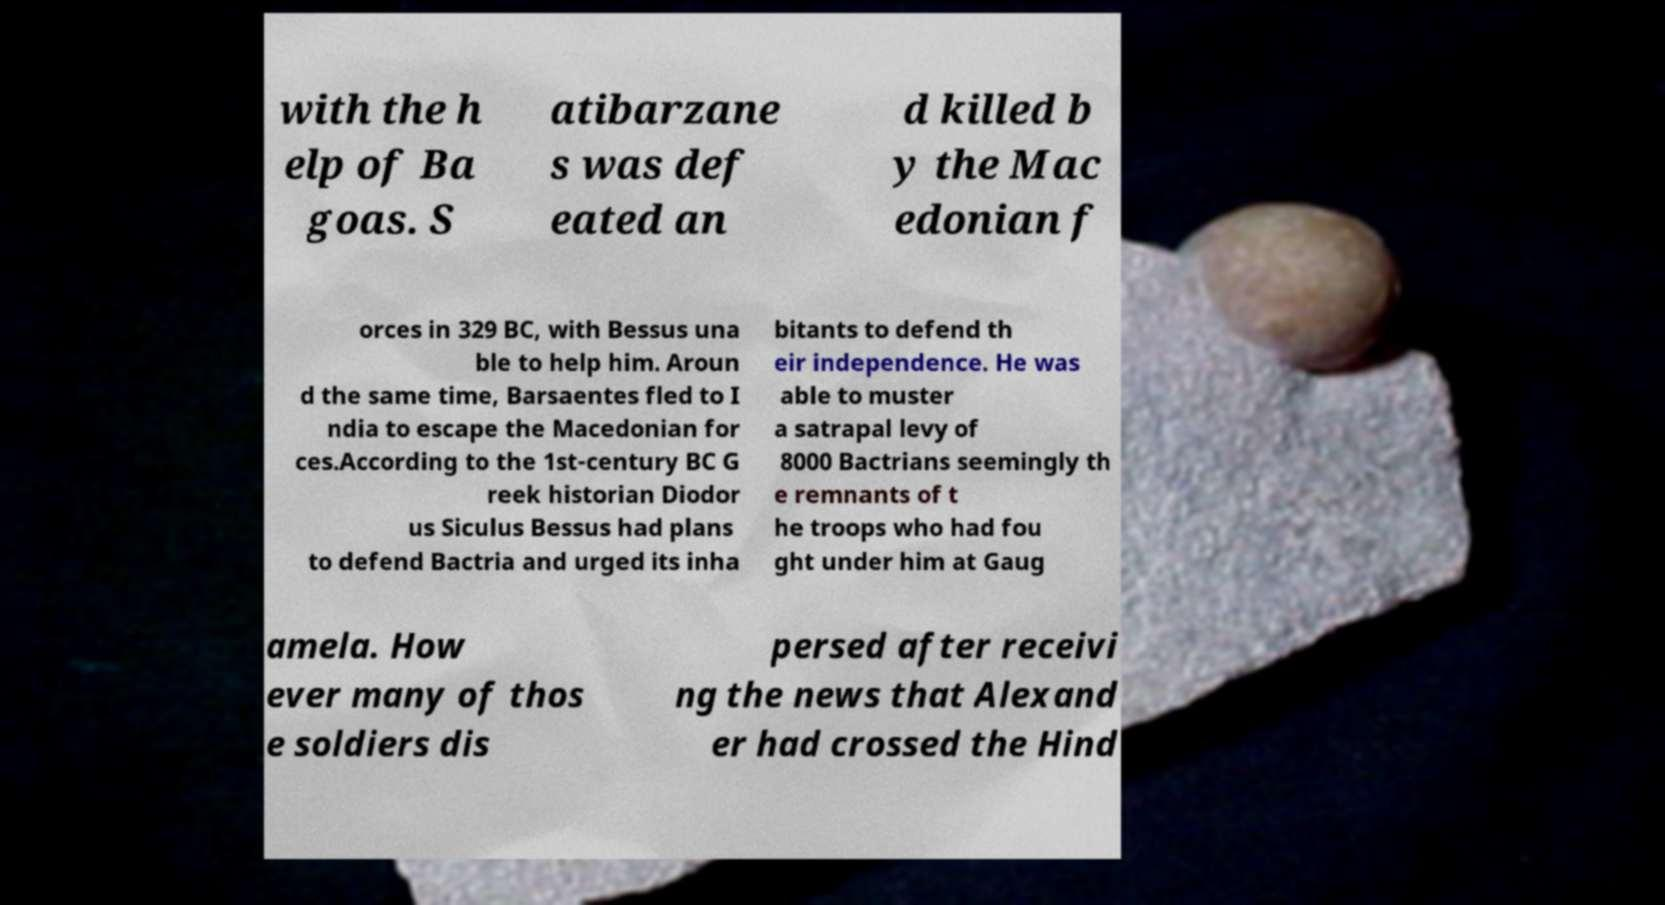Can you accurately transcribe the text from the provided image for me? with the h elp of Ba goas. S atibarzane s was def eated an d killed b y the Mac edonian f orces in 329 BC, with Bessus una ble to help him. Aroun d the same time, Barsaentes fled to I ndia to escape the Macedonian for ces.According to the 1st-century BC G reek historian Diodor us Siculus Bessus had plans to defend Bactria and urged its inha bitants to defend th eir independence. He was able to muster a satrapal levy of 8000 Bactrians seemingly th e remnants of t he troops who had fou ght under him at Gaug amela. How ever many of thos e soldiers dis persed after receivi ng the news that Alexand er had crossed the Hind 